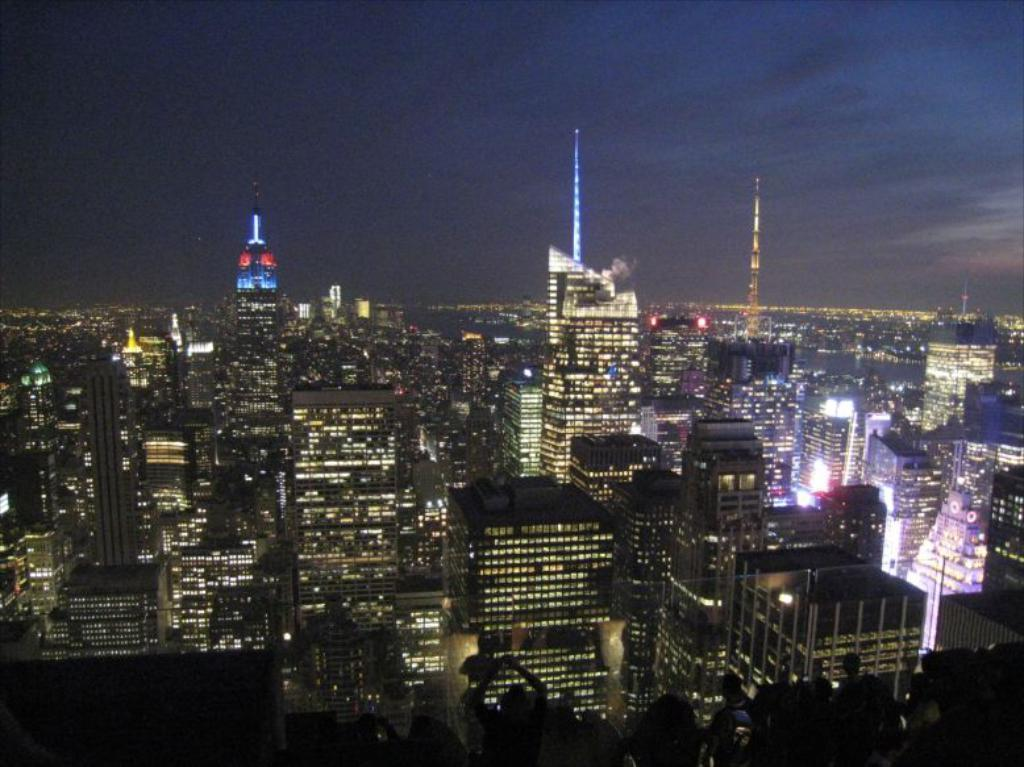What type of structures are present in the image? There are buildings in the image. What feature can be seen on the buildings? There are lights on the buildings. What can be seen in the background of the image? The sky is visible in the background of the image. What type of tail can be seen on the buildings in the image? There are no tails present on the buildings in the image. What adjustment can be made to the lights on the buildings in the image? The question assumes that there is a way to adjust the lights on the buildings, but this information is not provided in the facts. 